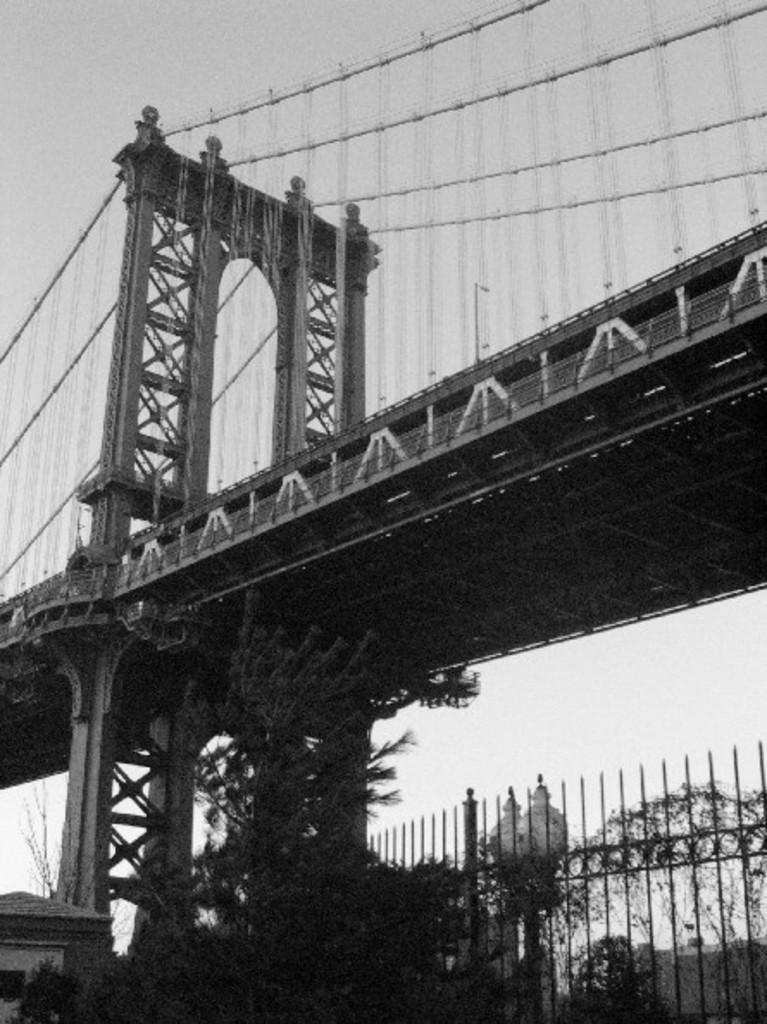What is the color scheme of the image? The image is black and white. What structure can be seen in the image? There is a bridge in the image. What type of barrier surrounds the bridge? There is fencing around the bridge. What type of vegetation is present in the image? There are trees on the ground in the image. What type of argument is taking place near the bridge in the image? There is no argument present in the image; it is a black and white image featuring a bridge with fencing and trees. What type of punishment is being administered to the trees in the image? There is no punishment being administered to the trees in the image; they are simply trees on the ground. 